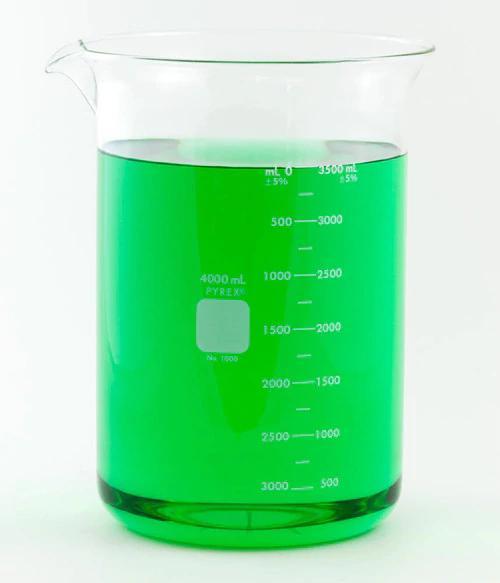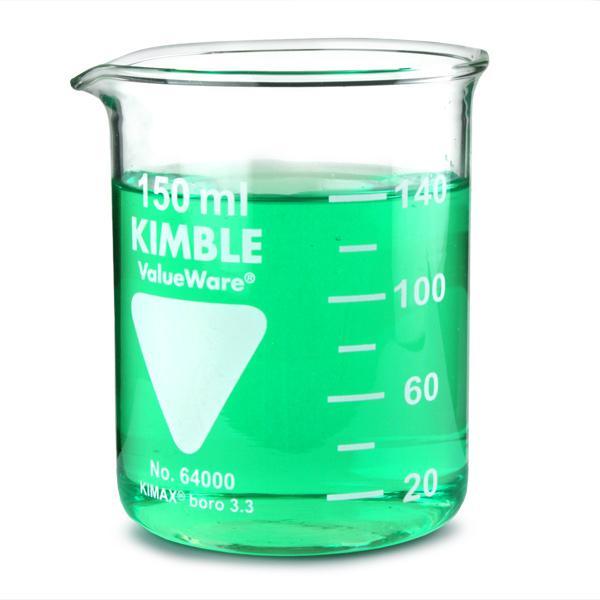The first image is the image on the left, the second image is the image on the right. Considering the images on both sides, is "The left beaker has a top mark labeled as 40 ml." valid? Answer yes or no. No. 